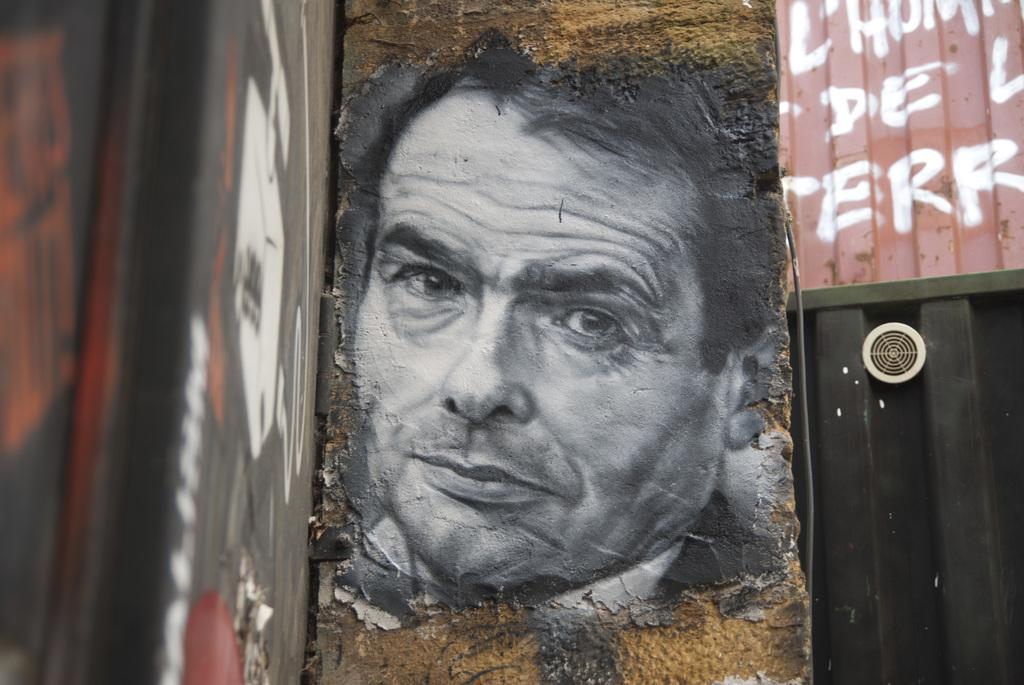What is depicted on the wall in the image? There is a painting of a man on a wall. Are there any other paintings in the image? Yes, there are paintings on the left and right walls. What else can be seen on the left and right walls? There is text on the left and right walls. What type of tax is being discussed in the painting on the left wall? There is no mention of tax or any discussion in the image; it only features paintings and text on the walls. 